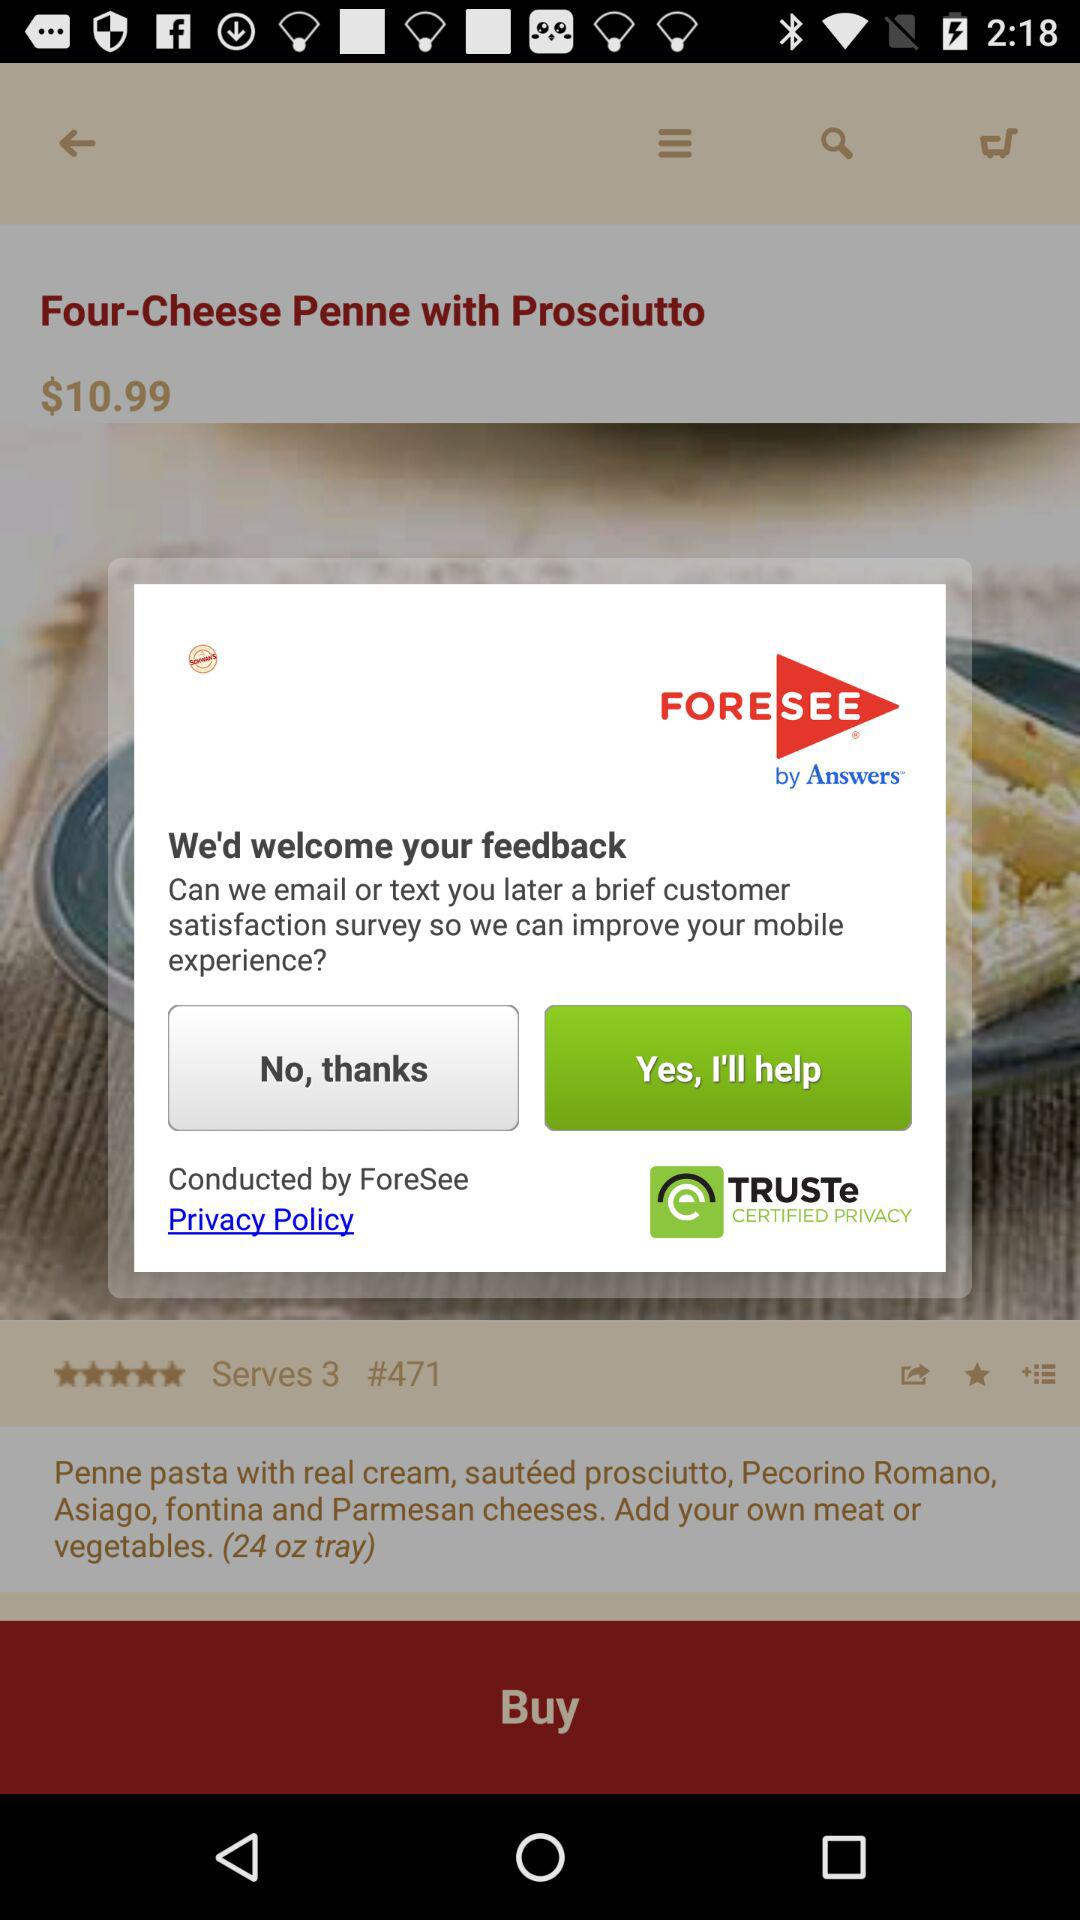What phone number will be texted for a brief customer satisfaction survey?
When the provided information is insufficient, respond with <no answer>. <no answer> 